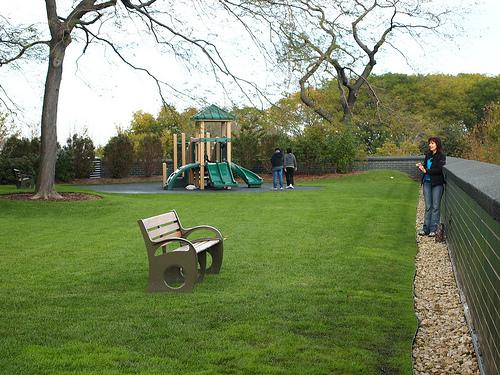What kind of interaction could be happening between the woman and the wall? The woman is standing and smiling next to the wall, possibly posing for a picture or observing something on the wall. What kind of flora can be observed in the image information? There are deciduous trees, bushes, and grass of varying shades of green. Provide an overall sentiment depicted in the image description. The image seems to depict a pleasant, peaceful environment of a park with people enjoying their time, trees, and greenery all around. What is the woman near the wall wearing on her upper body? The woman is wearing a blue shirt. List two objects that are situated on the grass. A bench and a large tree are situated on the grass. How many people are standing by the playground? Two people are standing by the playground. What is the common color of the tops of the playground equipment and the trees? The common color is green. Identify the color of the slides in the playground. The slides are green. Describe the wall mentioned in the image description. The wall is made of bricks and there is a black and green section. What kind of day is depicted in the image? It is a clear day with cloudy skies. Can you see the children playing on the slide? No, it's not mentioned in the image. Do you see the man wearing a green shirt? There is a mention of a man wearing green jeans, but not a green shirt; also, there's a woman wearing a blue shirt, which could lead to confusion. 